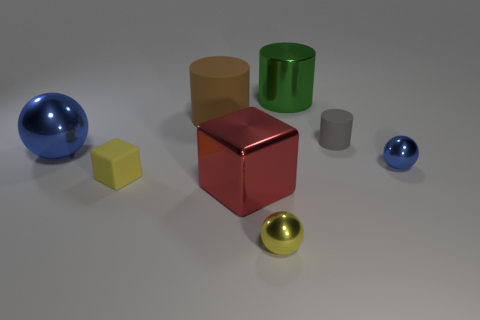Subtract all blue spheres. How many were subtracted if there are1blue spheres left? 1 Subtract all gray cylinders. How many cylinders are left? 2 Subtract all gray cubes. How many blue balls are left? 2 Add 1 large balls. How many objects exist? 9 Subtract all spheres. How many objects are left? 5 Add 5 gray matte objects. How many gray matte objects are left? 6 Add 7 green shiny things. How many green shiny things exist? 8 Subtract 1 yellow balls. How many objects are left? 7 Subtract all brown cylinders. Subtract all cyan blocks. How many cylinders are left? 2 Subtract all gray matte objects. Subtract all red metallic objects. How many objects are left? 6 